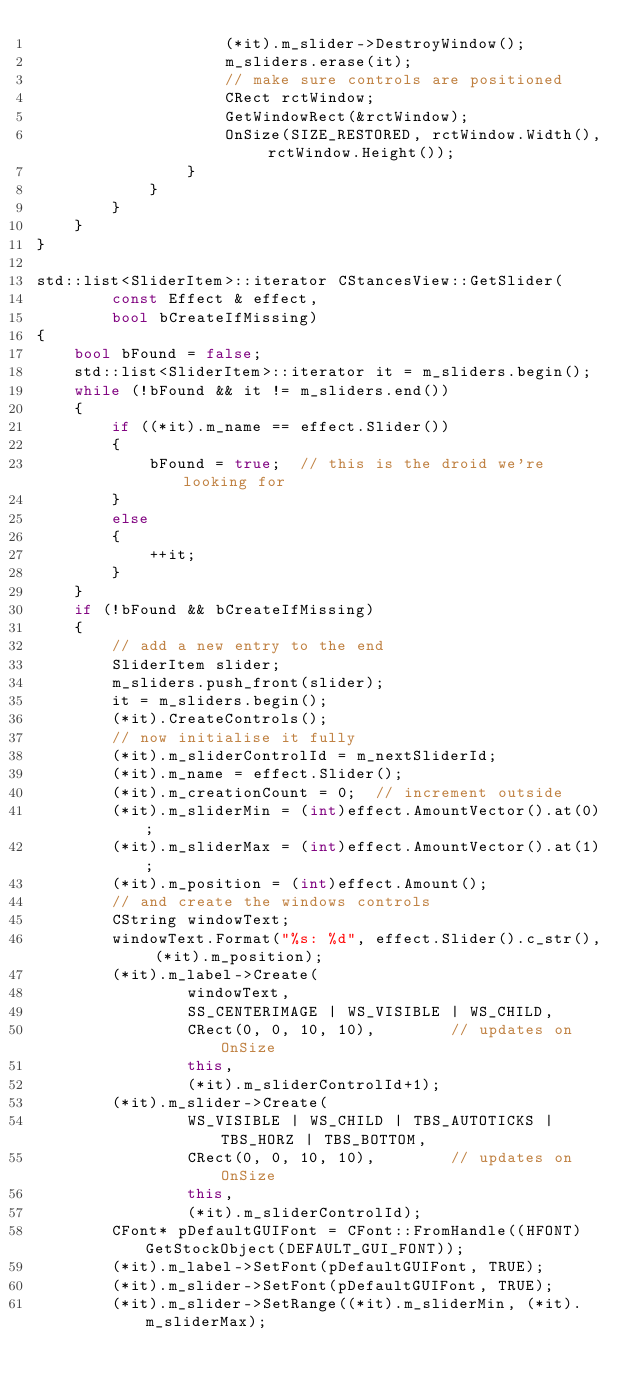Convert code to text. <code><loc_0><loc_0><loc_500><loc_500><_C++_>                    (*it).m_slider->DestroyWindow();
                    m_sliders.erase(it);
                    // make sure controls are positioned
                    CRect rctWindow;
                    GetWindowRect(&rctWindow);
                    OnSize(SIZE_RESTORED, rctWindow.Width(), rctWindow.Height());
                }
            }
        }
    }
}

std::list<SliderItem>::iterator CStancesView::GetSlider(
        const Effect & effect,
        bool bCreateIfMissing)
{
    bool bFound = false;
    std::list<SliderItem>::iterator it = m_sliders.begin();
    while (!bFound && it != m_sliders.end())
    {
        if ((*it).m_name == effect.Slider())
        {
            bFound = true;  // this is the droid we're looking for
        }
        else
        {
            ++it;
        }
    }
    if (!bFound && bCreateIfMissing)
    {
        // add a new entry to the end
        SliderItem slider;
        m_sliders.push_front(slider);
        it = m_sliders.begin();
        (*it).CreateControls();
        // now initialise it fully
        (*it).m_sliderControlId = m_nextSliderId;
        (*it).m_name = effect.Slider();
        (*it).m_creationCount = 0;  // increment outside
        (*it).m_sliderMin = (int)effect.AmountVector().at(0);
        (*it).m_sliderMax = (int)effect.AmountVector().at(1);
        (*it).m_position = (int)effect.Amount();
        // and create the windows controls
        CString windowText;
        windowText.Format("%s: %d", effect.Slider().c_str(), (*it).m_position);
        (*it).m_label->Create(
                windowText,
                SS_CENTERIMAGE | WS_VISIBLE | WS_CHILD,
                CRect(0, 0, 10, 10),        // updates on OnSize
                this,
                (*it).m_sliderControlId+1);
        (*it).m_slider->Create(
                WS_VISIBLE | WS_CHILD | TBS_AUTOTICKS | TBS_HORZ | TBS_BOTTOM,
                CRect(0, 0, 10, 10),        // updates on OnSize
                this,
                (*it).m_sliderControlId);
        CFont* pDefaultGUIFont = CFont::FromHandle((HFONT) GetStockObject(DEFAULT_GUI_FONT));
        (*it).m_label->SetFont(pDefaultGUIFont, TRUE);
        (*it).m_slider->SetFont(pDefaultGUIFont, TRUE);
        (*it).m_slider->SetRange((*it).m_sliderMin, (*it).m_sliderMax);</code> 